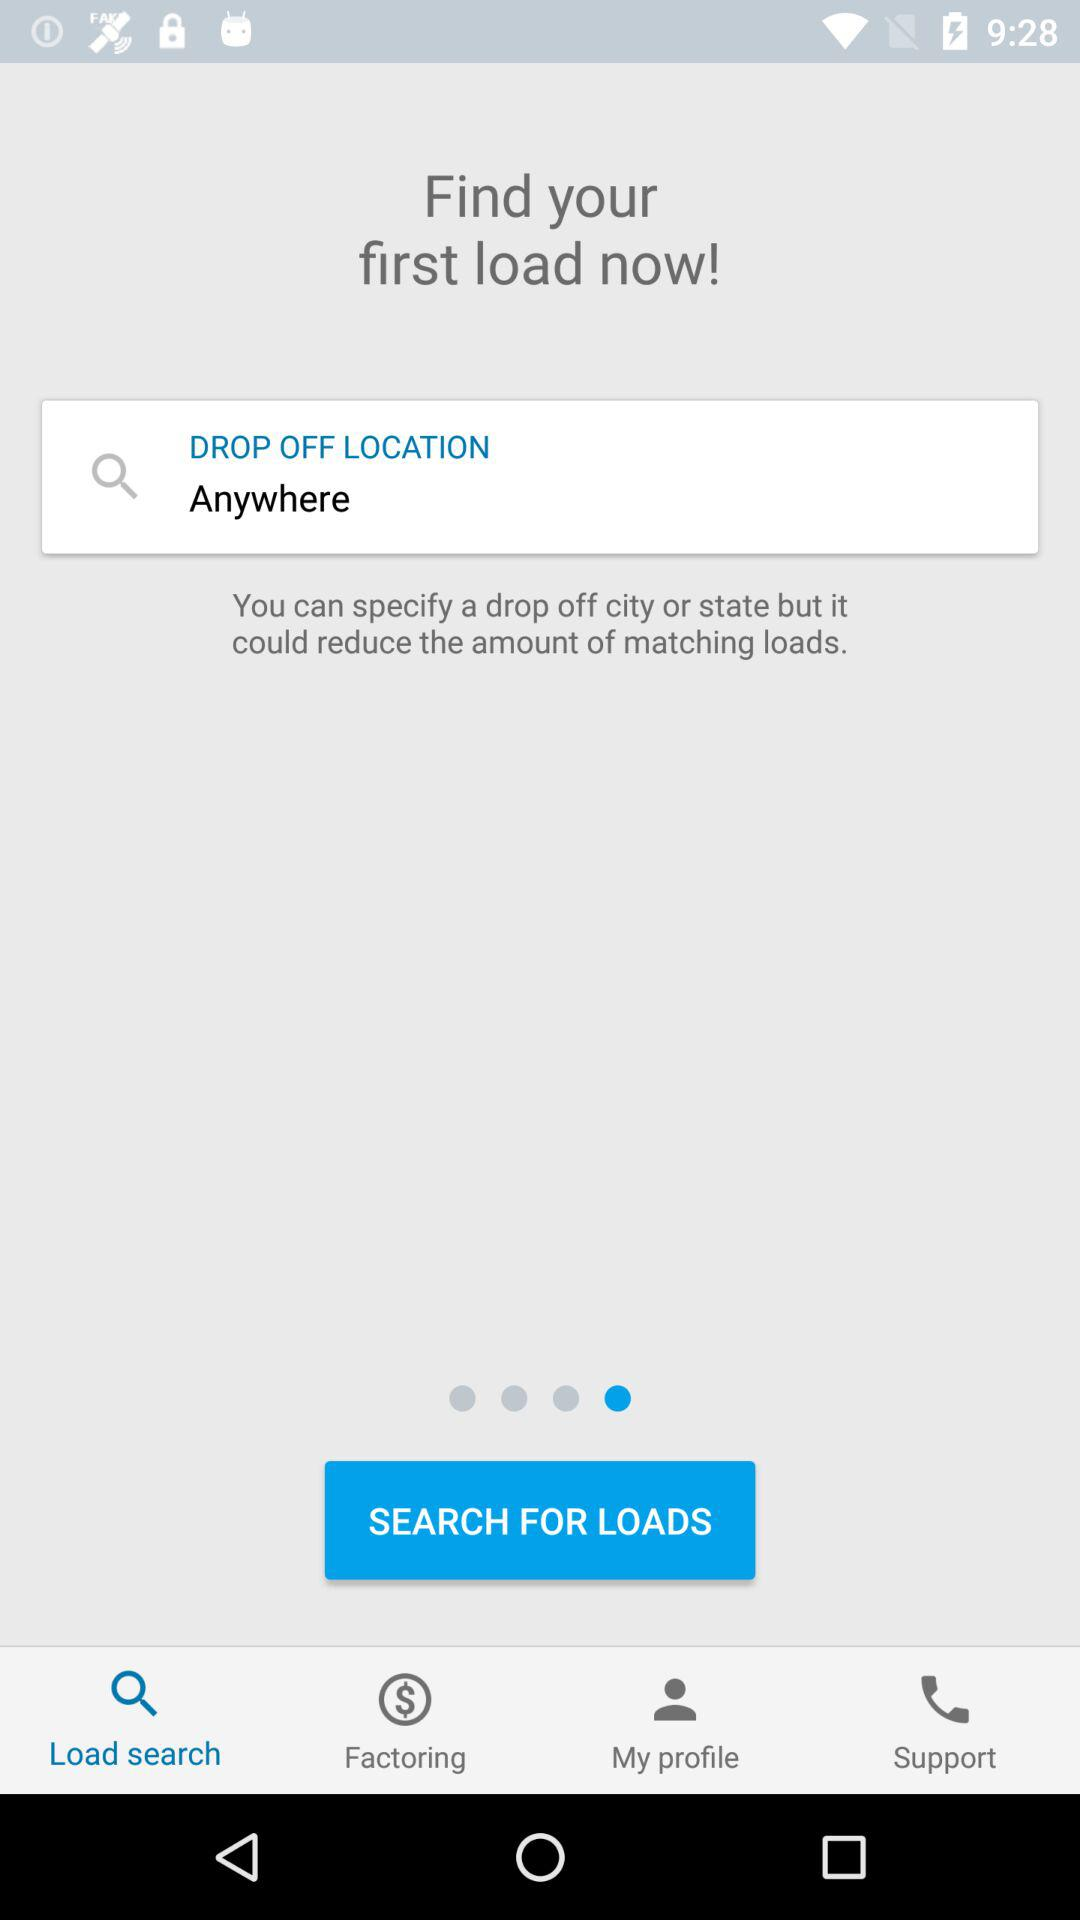Which option is selected? The selected option is "Load search". 